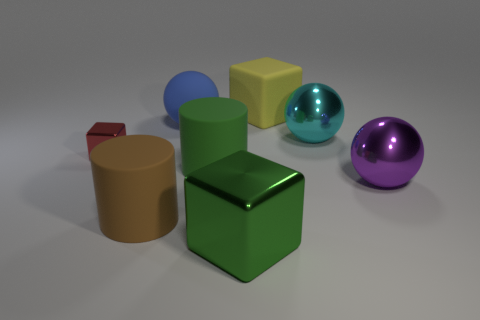Do the ball that is in front of the small red block and the large shiny sphere behind the small red metal block have the same color?
Ensure brevity in your answer.  No. Is the number of large green cylinders that are right of the brown object greater than the number of red shiny balls?
Ensure brevity in your answer.  Yes. What shape is the large blue object that is made of the same material as the large brown thing?
Give a very brief answer. Sphere. Does the metallic block in front of the red metal block have the same size as the big purple metal thing?
Keep it short and to the point. Yes. What shape is the big green object that is in front of the cylinder that is right of the big blue ball?
Keep it short and to the point. Cube. There is a cylinder that is behind the big brown rubber cylinder that is left of the purple object; what size is it?
Offer a terse response. Large. There is a cylinder right of the blue object; what is its color?
Your answer should be compact. Green. There is another cylinder that is the same material as the brown cylinder; what is its size?
Keep it short and to the point. Large. What number of purple metallic objects have the same shape as the blue rubber object?
Make the answer very short. 1. There is a cyan thing that is the same size as the purple object; what is its material?
Your answer should be very brief. Metal. 